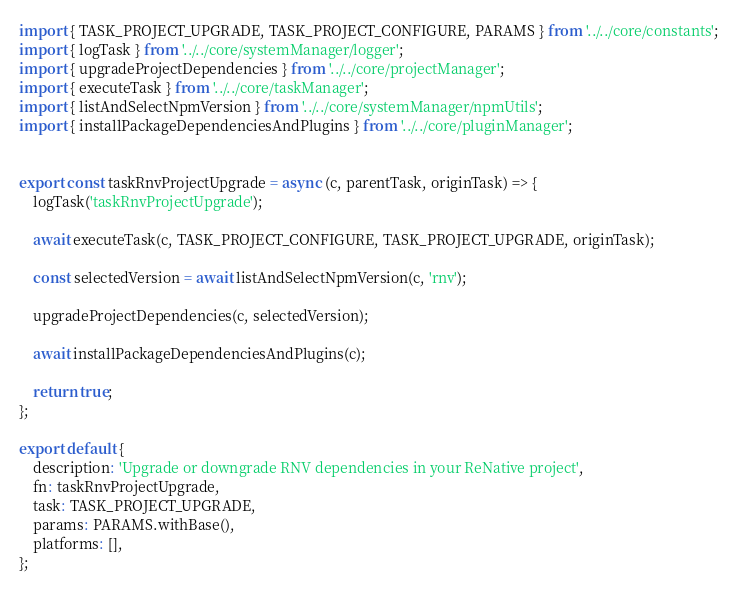<code> <loc_0><loc_0><loc_500><loc_500><_JavaScript_>import { TASK_PROJECT_UPGRADE, TASK_PROJECT_CONFIGURE, PARAMS } from '../../core/constants';
import { logTask } from '../../core/systemManager/logger';
import { upgradeProjectDependencies } from '../../core/projectManager';
import { executeTask } from '../../core/taskManager';
import { listAndSelectNpmVersion } from '../../core/systemManager/npmUtils';
import { installPackageDependenciesAndPlugins } from '../../core/pluginManager';


export const taskRnvProjectUpgrade = async (c, parentTask, originTask) => {
    logTask('taskRnvProjectUpgrade');

    await executeTask(c, TASK_PROJECT_CONFIGURE, TASK_PROJECT_UPGRADE, originTask);

    const selectedVersion = await listAndSelectNpmVersion(c, 'rnv');

    upgradeProjectDependencies(c, selectedVersion);

    await installPackageDependenciesAndPlugins(c);

    return true;
};

export default {
    description: 'Upgrade or downgrade RNV dependencies in your ReNative project',
    fn: taskRnvProjectUpgrade,
    task: TASK_PROJECT_UPGRADE,
    params: PARAMS.withBase(),
    platforms: [],
};
</code> 